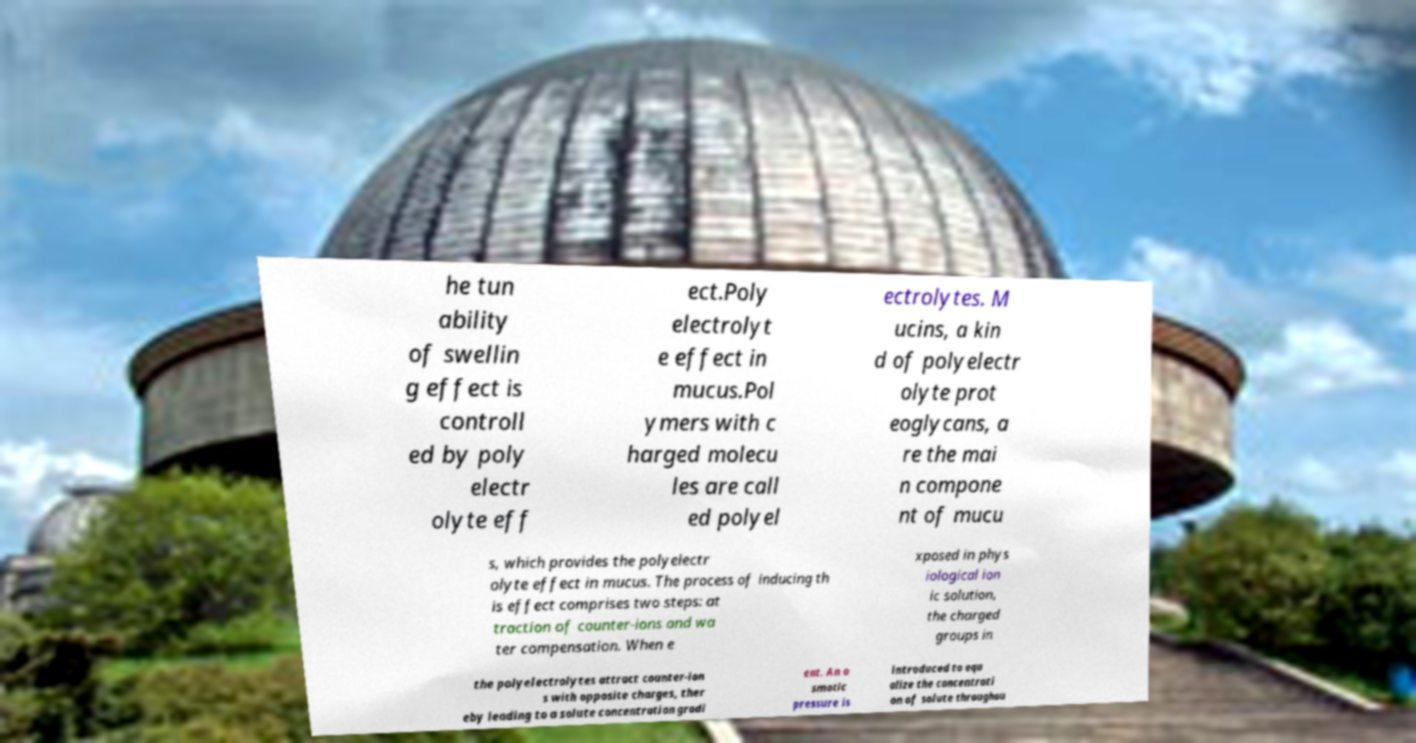Please read and relay the text visible in this image. What does it say? he tun ability of swellin g effect is controll ed by poly electr olyte eff ect.Poly electrolyt e effect in mucus.Pol ymers with c harged molecu les are call ed polyel ectrolytes. M ucins, a kin d of polyelectr olyte prot eoglycans, a re the mai n compone nt of mucu s, which provides the polyelectr olyte effect in mucus. The process of inducing th is effect comprises two steps: at traction of counter-ions and wa ter compensation. When e xposed in phys iological ion ic solution, the charged groups in the polyelectrolytes attract counter-ion s with opposite charges, ther eby leading to a solute concentration gradi ent. An o smotic pressure is introduced to equ alize the concentrati on of solute throughou 